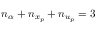<formula> <loc_0><loc_0><loc_500><loc_500>n _ { \alpha } + n _ { x _ { p } } + n _ { u _ { p } } = 3</formula> 